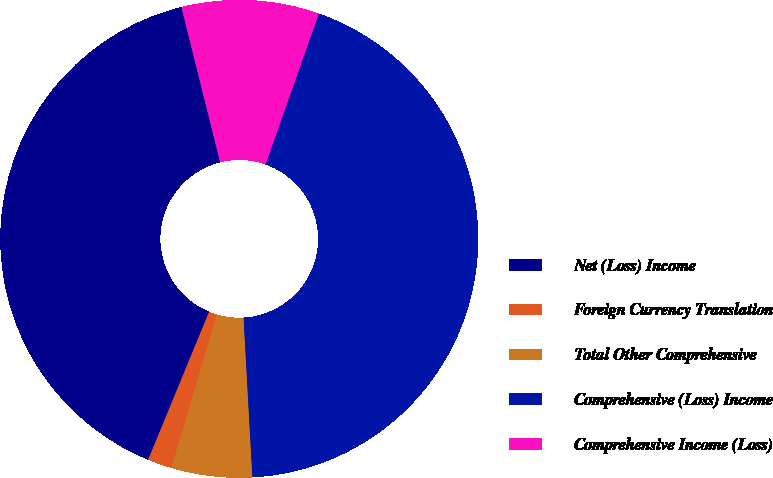Convert chart to OTSL. <chart><loc_0><loc_0><loc_500><loc_500><pie_chart><fcel>Net (Loss) Income<fcel>Foreign Currency Translation<fcel>Total Other Comprehensive<fcel>Comprehensive (Loss) Income<fcel>Comprehensive Income (Loss)<nl><fcel>39.89%<fcel>1.64%<fcel>5.46%<fcel>43.72%<fcel>9.29%<nl></chart> 